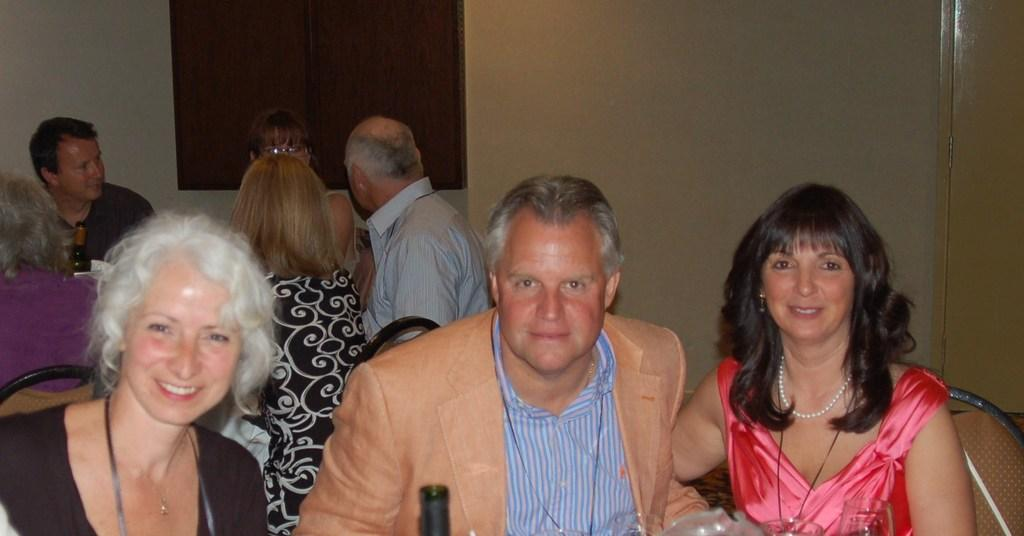What are the people in the image doing? The people in the image are sitting on chairs. What can be seen in the background of the image? There is a wall and a window in the background of the image. Where is the door located in the image? The door is on the right side of the image. What flavor of ice cream does the owner of the door prefer? There is no information about the owner of the door or their ice cream preferences in the image. 